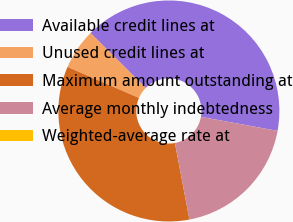Convert chart to OTSL. <chart><loc_0><loc_0><loc_500><loc_500><pie_chart><fcel>Available credit lines at<fcel>Unused credit lines at<fcel>Maximum amount outstanding at<fcel>Average monthly indebtedness<fcel>Weighted-average rate at<nl><fcel>40.43%<fcel>5.93%<fcel>34.5%<fcel>19.14%<fcel>0.0%<nl></chart> 